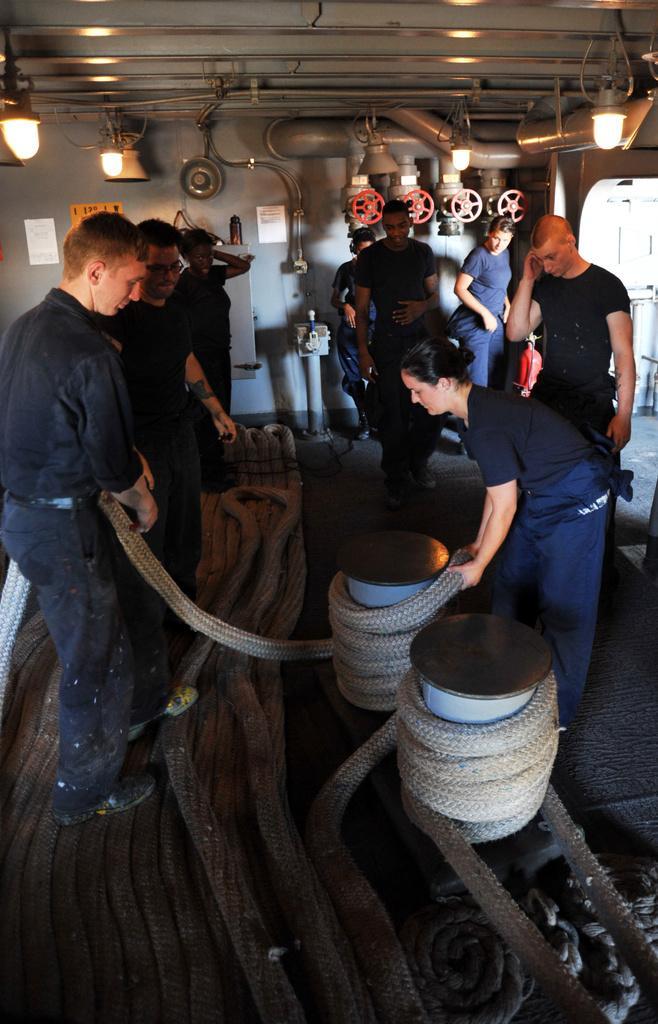Can you describe this image briefly? In this picture I see the ropes in front and I see number of people in which I see a man and a woman who are holding the ropes. In the background I see few equipment and I see the lights on the top of this image. 